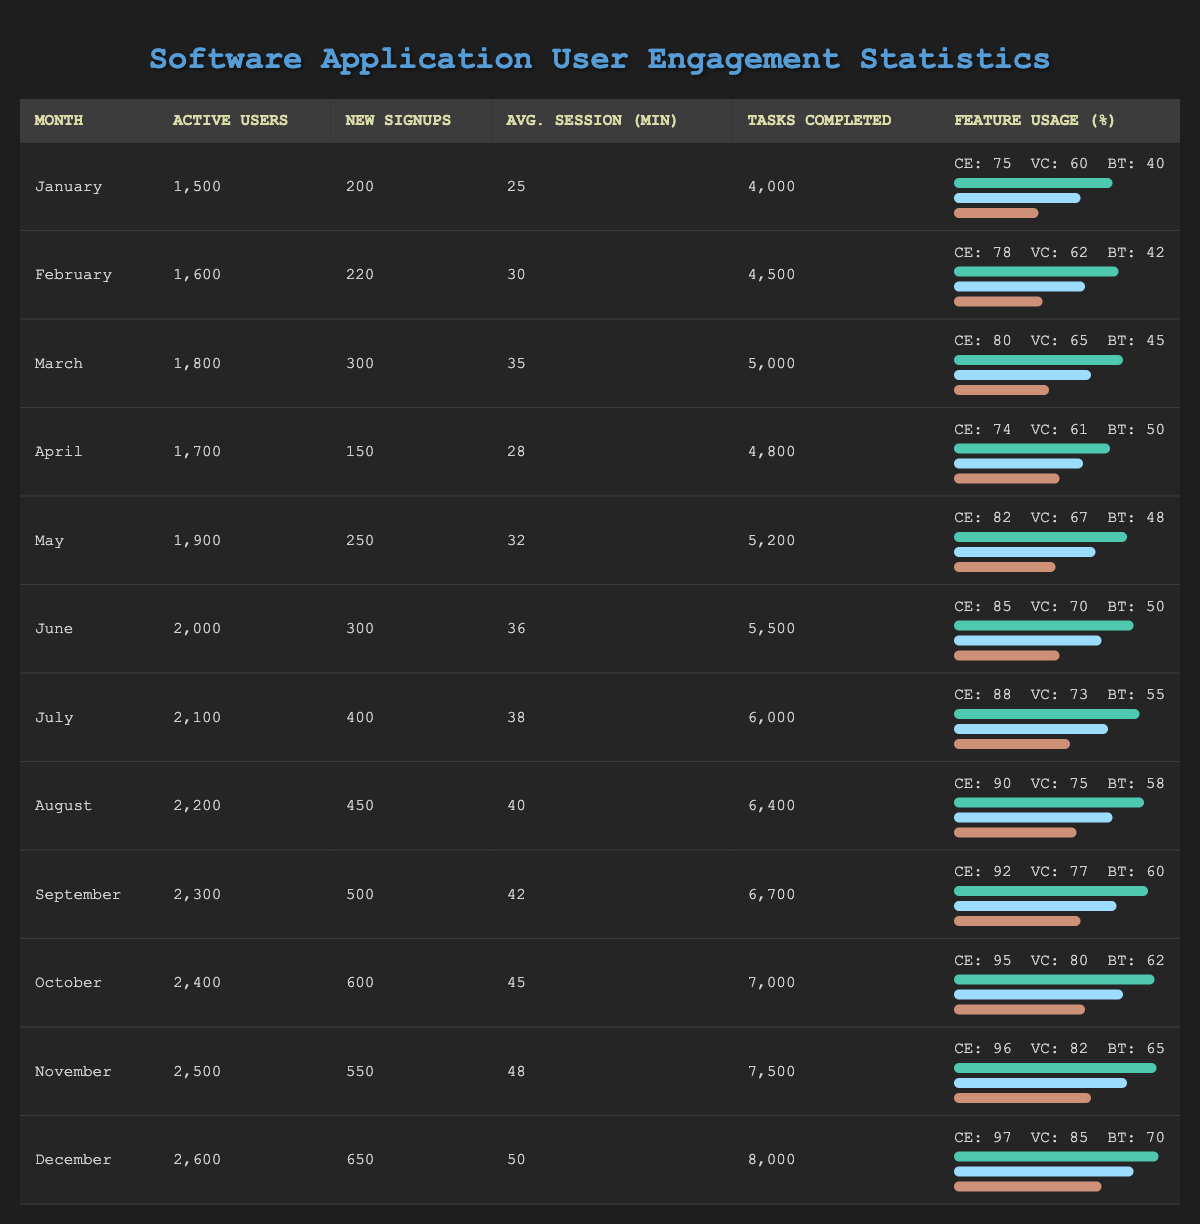What is the total number of active users in December? Referring directly to the table, the number of active users for December is listed as 2600.
Answer: 2600 Which month has the highest average session length in minutes? Looking at the table, the highest average session length is found in December at 50 minutes.
Answer: December How many new signups were there from July to September combined? The new signups for July, August, and September are 400, 450, and 500 respectively. Adding these gives us 400 + 450 + 500 = 1350 new signups combined.
Answer: 1350 Did the tasks completed increase from January to December? By looking at the tasks completed for January (4000) and December (8000), we see that December has more tasks completed compared to January, confirming an increase over the year.
Answer: Yes What is the percentage increase of active users from January to March? The number of active users in January is 1500 and in March it is 1800. The increase is 1800 - 1500 = 300. The percentage increase is then (300 / 1500) * 100 = 20%.
Answer: 20% Which feature showed the highest usage percentage in November? In November, the feature usage percentages are 96 for code editor, 82 for version control, and 65 for bug tracker. The highest is 96 for code editor.
Answer: Code editor Was there a decrease in new signups from August to October? New signups for August is 450, for September is 500, and for October is 600. The values show an increase, not a decrease, from August to October.
Answer: No What is the average number of tasks completed per month over the year? The total tasks completed in the year can be calculated by summing all monthly values: 4000 + 4500 + 5000 + 4800 + 5200 + 5500 + 6000 + 6400 + 6700 + 7000 + 7500 + 8000 = 63700. There are 12 months, so the average is 63700 / 12 = approximately 5291.67.
Answer: 5291.67 Which month had the lowest feature usage for version control? By examining the feature usage for version control across all months, the lowest recorded percentage is in January at 60%.
Answer: January In which month did the tasks completed exceed 6000 for the first time? Referring to the table, we can see that the first month where tasks completed exceeded 6000 is July, with 6000 completed tasks.
Answer: July 